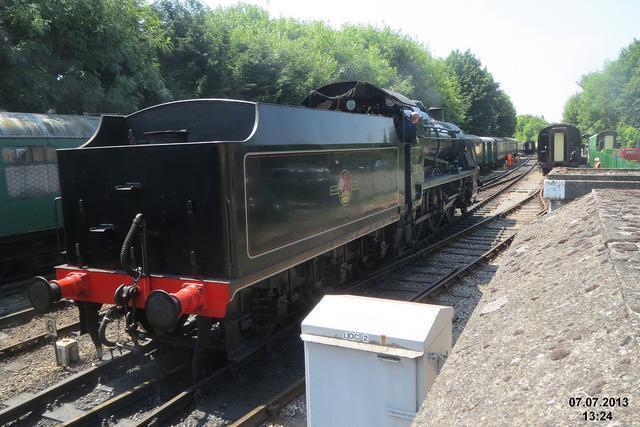The purpose of the train car behind the train engine is to hold what?
Answer the question by selecting the correct answer among the 4 following choices.
Options: Water, coal, cargo, passengers. Coal. 